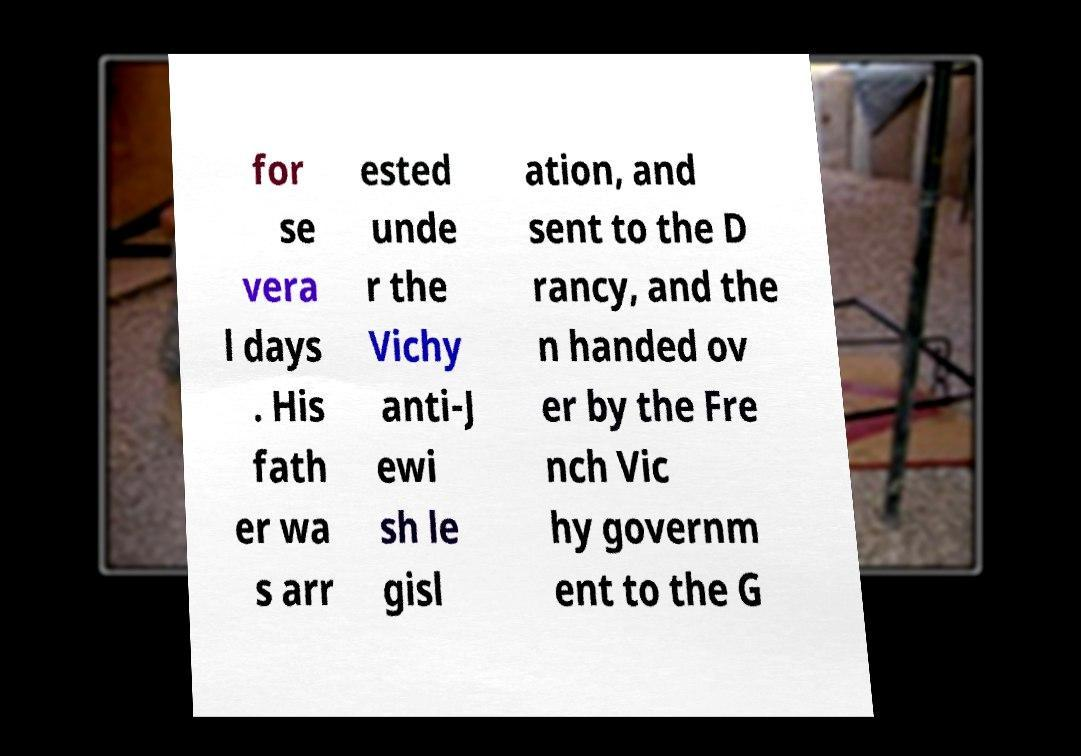Can you read and provide the text displayed in the image?This photo seems to have some interesting text. Can you extract and type it out for me? for se vera l days . His fath er wa s arr ested unde r the Vichy anti-J ewi sh le gisl ation, and sent to the D rancy, and the n handed ov er by the Fre nch Vic hy governm ent to the G 